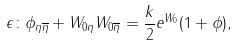<formula> <loc_0><loc_0><loc_500><loc_500>\epsilon \colon \phi _ { \eta \overline { \eta } } + W _ { 0 \eta } W _ { 0 \overline { \eta } } = \frac { k } { 2 } e ^ { W _ { 0 } } ( 1 + \phi ) ,</formula> 